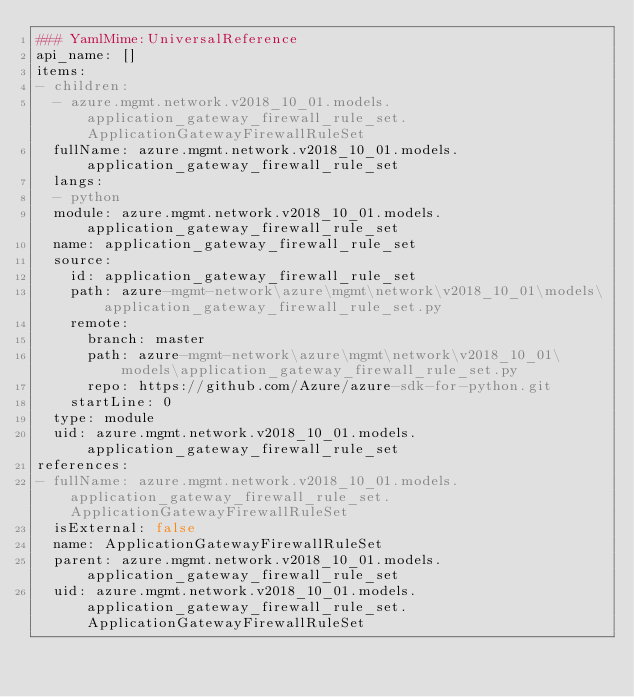<code> <loc_0><loc_0><loc_500><loc_500><_YAML_>### YamlMime:UniversalReference
api_name: []
items:
- children:
  - azure.mgmt.network.v2018_10_01.models.application_gateway_firewall_rule_set.ApplicationGatewayFirewallRuleSet
  fullName: azure.mgmt.network.v2018_10_01.models.application_gateway_firewall_rule_set
  langs:
  - python
  module: azure.mgmt.network.v2018_10_01.models.application_gateway_firewall_rule_set
  name: application_gateway_firewall_rule_set
  source:
    id: application_gateway_firewall_rule_set
    path: azure-mgmt-network\azure\mgmt\network\v2018_10_01\models\application_gateway_firewall_rule_set.py
    remote:
      branch: master
      path: azure-mgmt-network\azure\mgmt\network\v2018_10_01\models\application_gateway_firewall_rule_set.py
      repo: https://github.com/Azure/azure-sdk-for-python.git
    startLine: 0
  type: module
  uid: azure.mgmt.network.v2018_10_01.models.application_gateway_firewall_rule_set
references:
- fullName: azure.mgmt.network.v2018_10_01.models.application_gateway_firewall_rule_set.ApplicationGatewayFirewallRuleSet
  isExternal: false
  name: ApplicationGatewayFirewallRuleSet
  parent: azure.mgmt.network.v2018_10_01.models.application_gateway_firewall_rule_set
  uid: azure.mgmt.network.v2018_10_01.models.application_gateway_firewall_rule_set.ApplicationGatewayFirewallRuleSet
</code> 